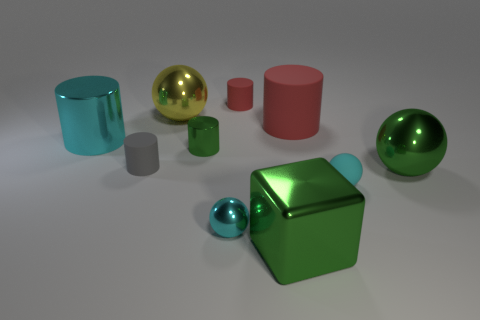What number of things are green metal balls or shiny cylinders?
Ensure brevity in your answer.  3. What color is the large cylinder that is to the right of the large cube?
Provide a succinct answer. Red. There is a cyan shiny thing that is the same shape as the big red rubber thing; what size is it?
Offer a terse response. Large. How many objects are small things that are to the right of the yellow metal ball or red cylinders behind the large red rubber thing?
Offer a very short reply. 4. What size is the green shiny thing that is both left of the big matte cylinder and in front of the gray thing?
Your answer should be compact. Large. There is a gray matte thing; is it the same shape as the small thing behind the tiny green thing?
Provide a succinct answer. Yes. How many things are spheres behind the gray rubber thing or tiny spheres?
Make the answer very short. 3. Does the large block have the same material as the red cylinder that is to the left of the large block?
Your response must be concise. No. What is the shape of the cyan thing left of the tiny metal thing in front of the green metal sphere?
Your answer should be compact. Cylinder. There is a large metal cylinder; does it have the same color as the big cube that is to the left of the big green metallic sphere?
Your response must be concise. No. 